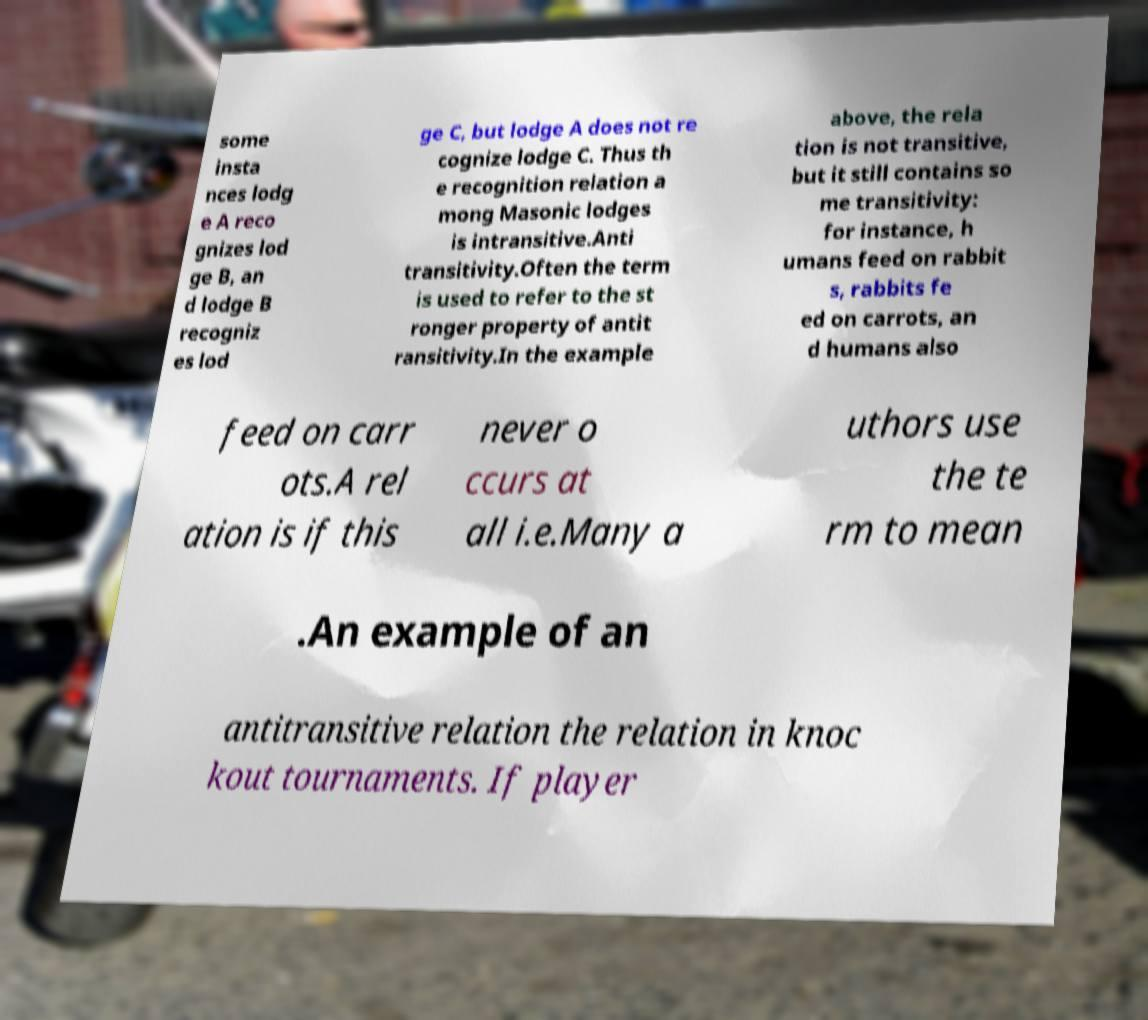Please read and relay the text visible in this image. What does it say? some insta nces lodg e A reco gnizes lod ge B, an d lodge B recogniz es lod ge C, but lodge A does not re cognize lodge C. Thus th e recognition relation a mong Masonic lodges is intransitive.Anti transitivity.Often the term is used to refer to the st ronger property of antit ransitivity.In the example above, the rela tion is not transitive, but it still contains so me transitivity: for instance, h umans feed on rabbit s, rabbits fe ed on carrots, an d humans also feed on carr ots.A rel ation is if this never o ccurs at all i.e.Many a uthors use the te rm to mean .An example of an antitransitive relation the relation in knoc kout tournaments. If player 